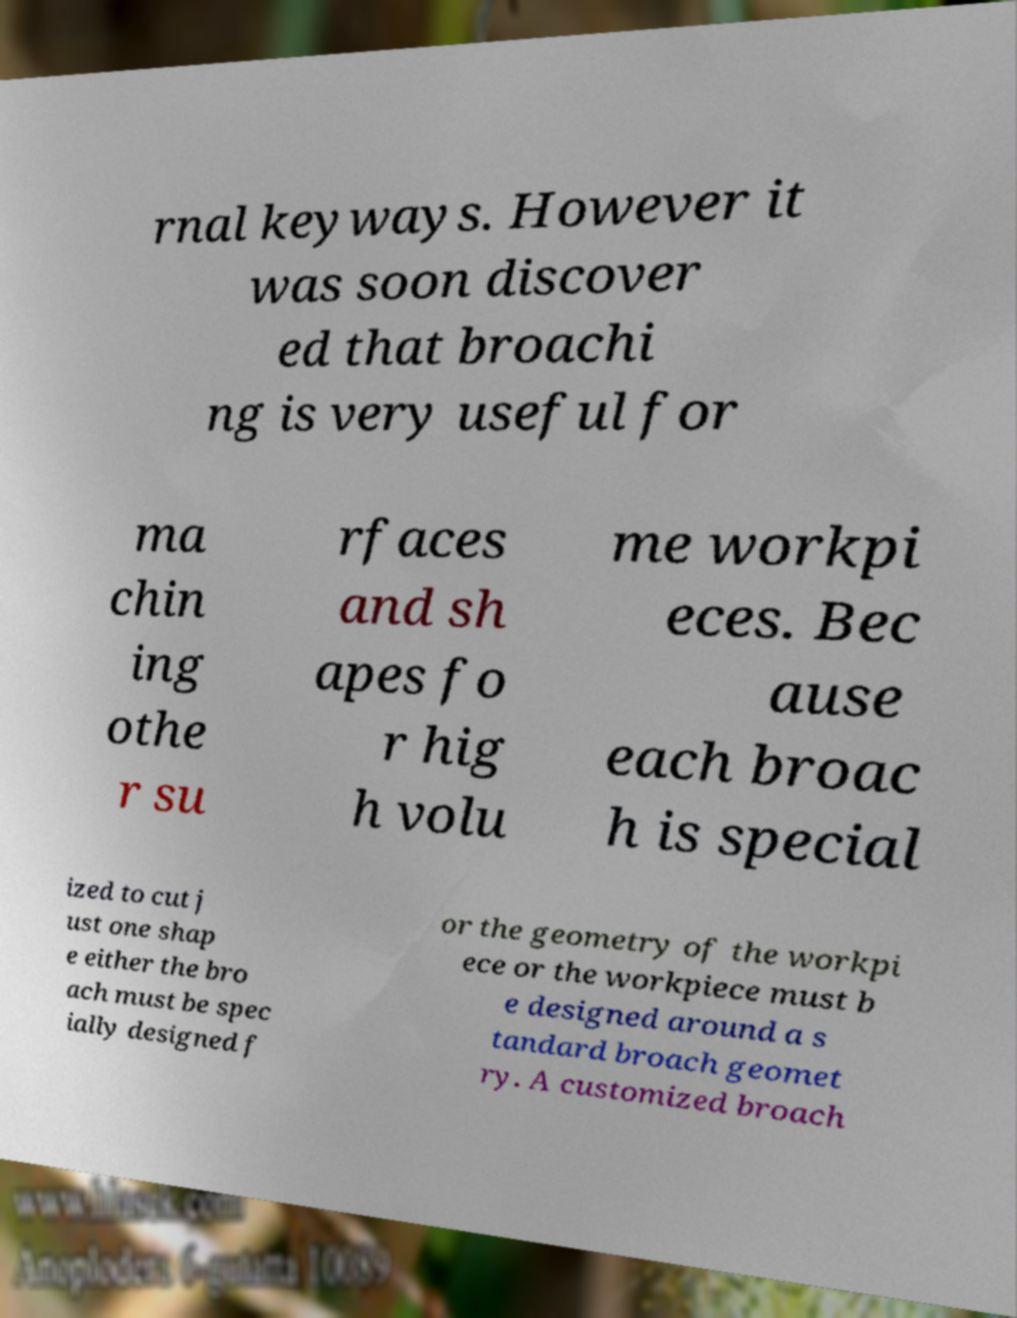Could you extract and type out the text from this image? rnal keyways. However it was soon discover ed that broachi ng is very useful for ma chin ing othe r su rfaces and sh apes fo r hig h volu me workpi eces. Bec ause each broac h is special ized to cut j ust one shap e either the bro ach must be spec ially designed f or the geometry of the workpi ece or the workpiece must b e designed around a s tandard broach geomet ry. A customized broach 